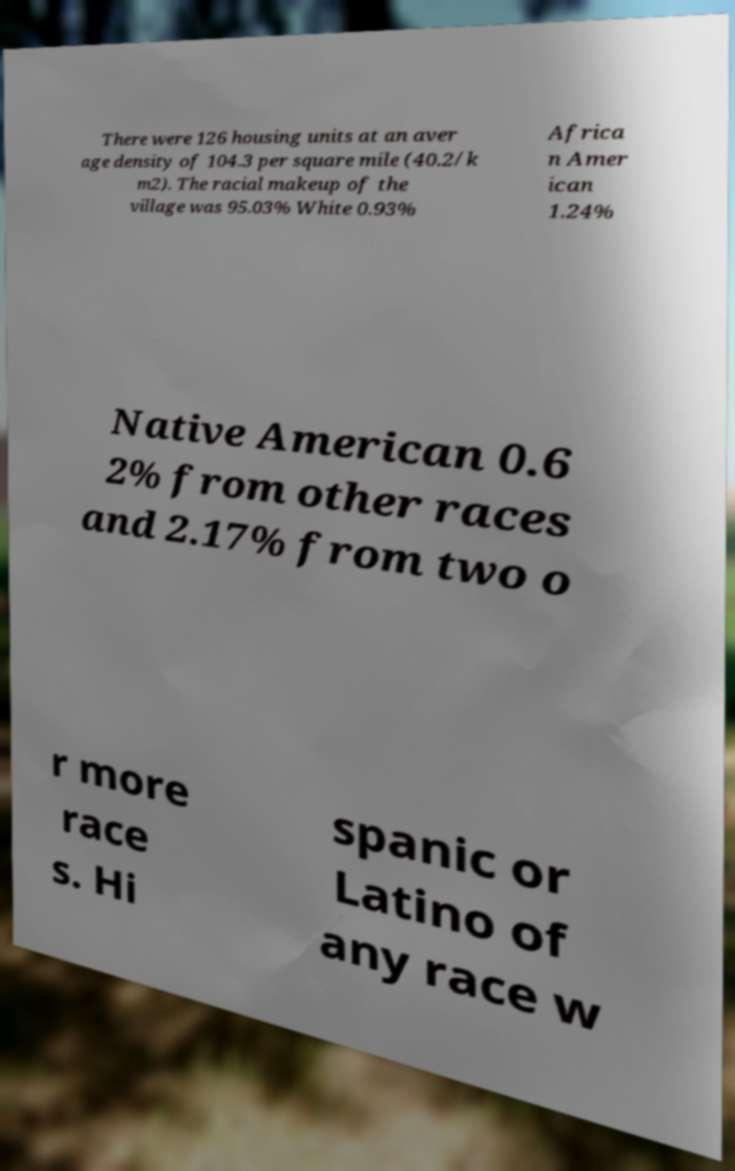Please read and relay the text visible in this image. What does it say? There were 126 housing units at an aver age density of 104.3 per square mile (40.2/k m2). The racial makeup of the village was 95.03% White 0.93% Africa n Amer ican 1.24% Native American 0.6 2% from other races and 2.17% from two o r more race s. Hi spanic or Latino of any race w 